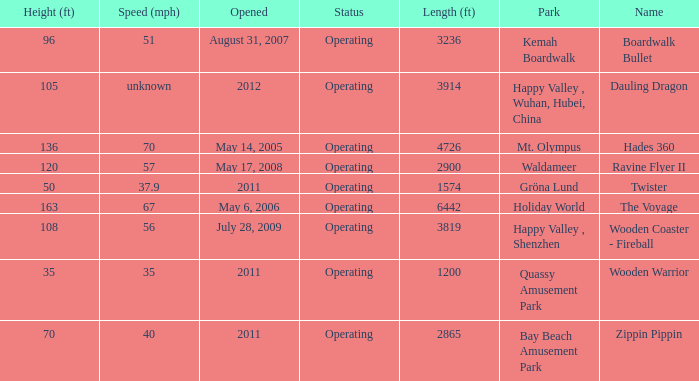What is the speed of the 163-feet tall roller coaster? 67.0. 